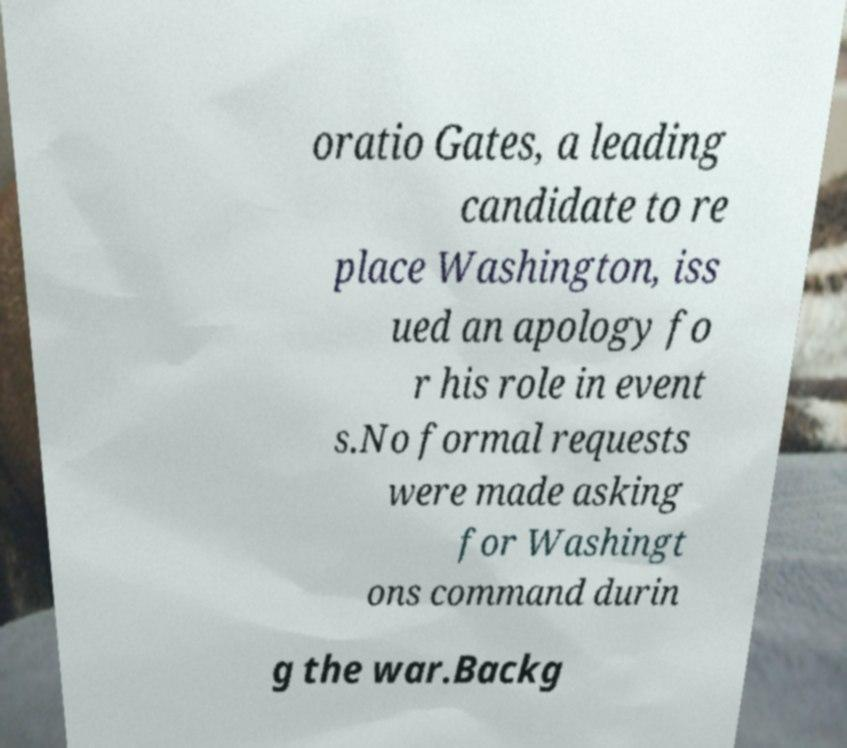Please read and relay the text visible in this image. What does it say? oratio Gates, a leading candidate to re place Washington, iss ued an apology fo r his role in event s.No formal requests were made asking for Washingt ons command durin g the war.Backg 